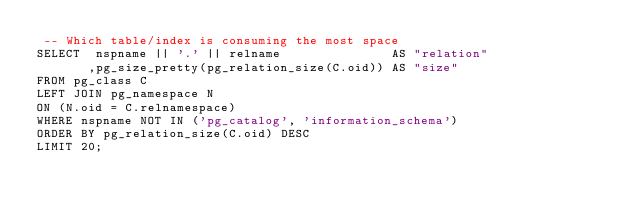Convert code to text. <code><loc_0><loc_0><loc_500><loc_500><_SQL_> -- Which table/index is consuming the most space
SELECT  nspname || '.' || relname               AS "relation"
       ,pg_size_pretty(pg_relation_size(C.oid)) AS "size"
FROM pg_class C
LEFT JOIN pg_namespace N
ON (N.oid = C.relnamespace)
WHERE nspname NOT IN ('pg_catalog', 'information_schema')
ORDER BY pg_relation_size(C.oid) DESC 
LIMIT 20;</code> 